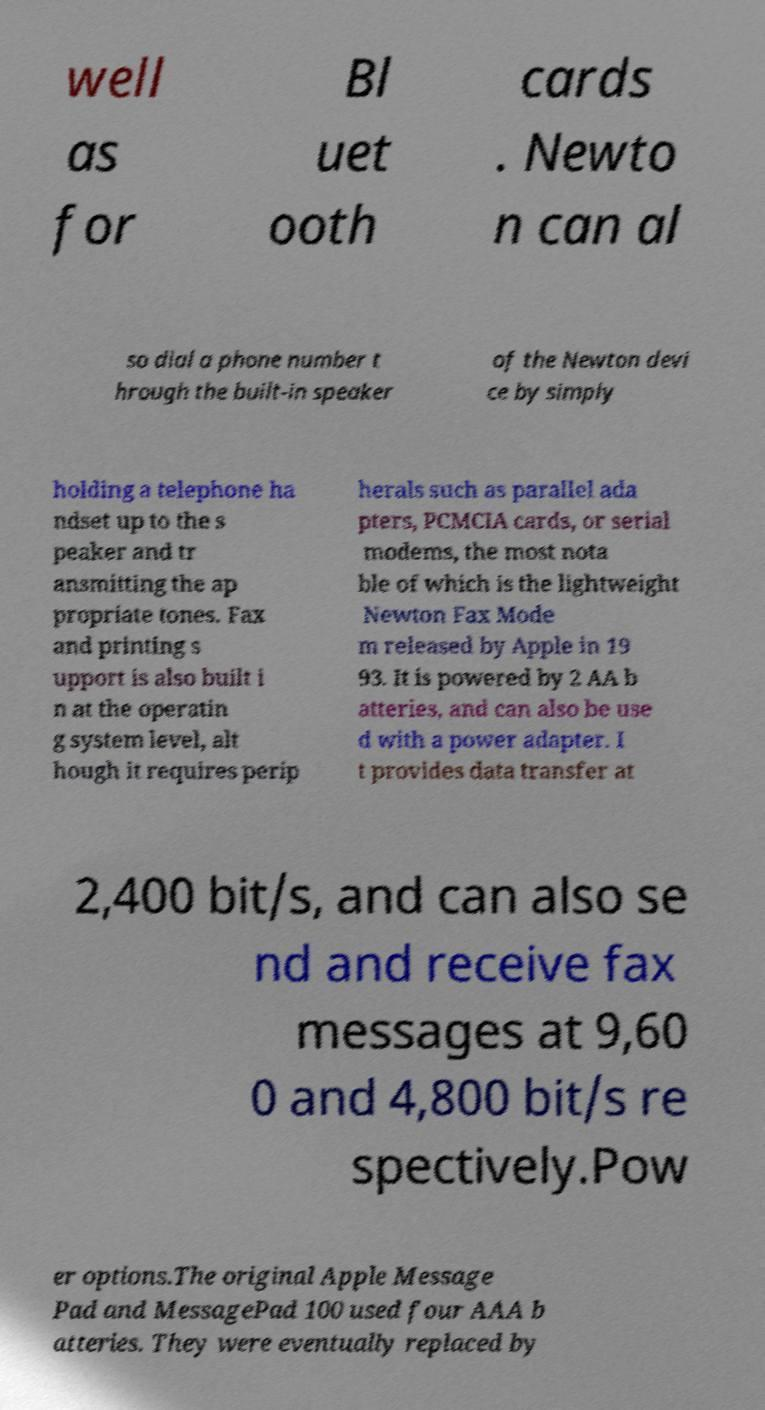Can you accurately transcribe the text from the provided image for me? well as for Bl uet ooth cards . Newto n can al so dial a phone number t hrough the built-in speaker of the Newton devi ce by simply holding a telephone ha ndset up to the s peaker and tr ansmitting the ap propriate tones. Fax and printing s upport is also built i n at the operatin g system level, alt hough it requires perip herals such as parallel ada pters, PCMCIA cards, or serial modems, the most nota ble of which is the lightweight Newton Fax Mode m released by Apple in 19 93. It is powered by 2 AA b atteries, and can also be use d with a power adapter. I t provides data transfer at 2,400 bit/s, and can also se nd and receive fax messages at 9,60 0 and 4,800 bit/s re spectively.Pow er options.The original Apple Message Pad and MessagePad 100 used four AAA b atteries. They were eventually replaced by 